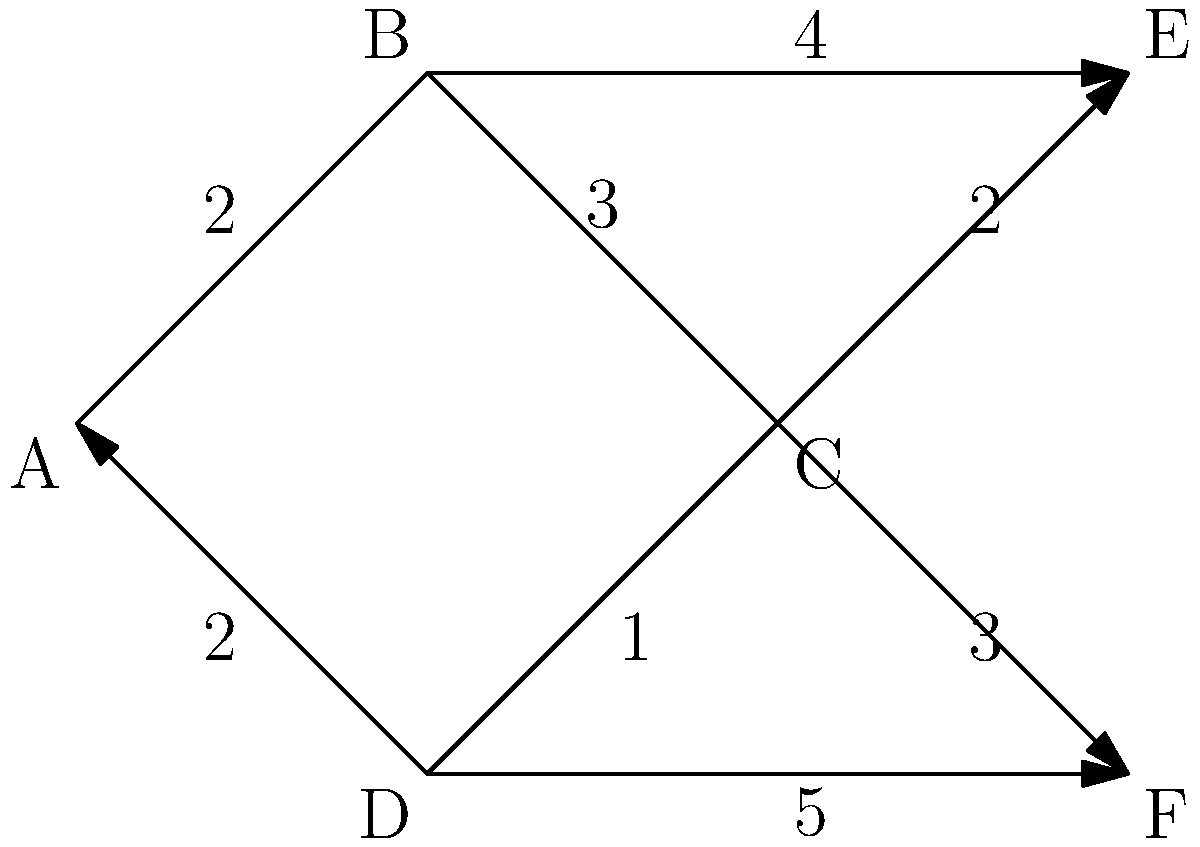As a law student interested in network topology, consider the following network diagram. What is the most efficient routing path from node A to node E, and what is its total cost? To find the most efficient routing path from node A to node E, we need to consider all possible paths and their associated costs. Let's break this down step-by-step:

1. Identify possible paths:
   - A → B → E
   - A → B → C → E
   - A → D → C → E

2. Calculate the cost of each path:
   - A → B → E: 2 + 4 = 6
   - A → B → C → E: 2 + 3 + 2 = 7
   - A → D → C → E: 2 + 1 + 2 = 5

3. Compare the costs:
   The path with the lowest total cost is A → D → C → E, with a total cost of 5.

4. Verify that this is indeed the most efficient path:
   - There are no other possible paths that could yield a lower cost.
   - This path utilizes the shortest connections available (cost of 1 and 2) to reach the destination.

Therefore, the most efficient routing path from A to E is A → D → C → E, with a total cost of 5.
Answer: A → D → C → E, cost: 5 